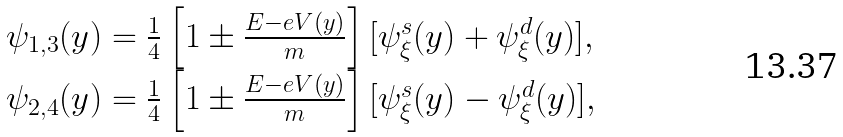<formula> <loc_0><loc_0><loc_500><loc_500>\begin{array} { l } \psi _ { 1 , 3 } ( y ) = \frac { 1 } { 4 } \left [ 1 \pm \frac { E - e V ( y ) } { m } \right ] [ \psi _ { \xi } ^ { s } ( y ) + \psi _ { \xi } ^ { d } ( y ) ] , \\ \psi _ { 2 , 4 } ( y ) = \frac { 1 } { 4 } \left [ 1 \pm \frac { E - e V ( y ) } { m } \right ] [ \psi _ { \xi } ^ { s } ( y ) - \psi _ { \xi } ^ { d } ( y ) ] , \end{array}</formula> 